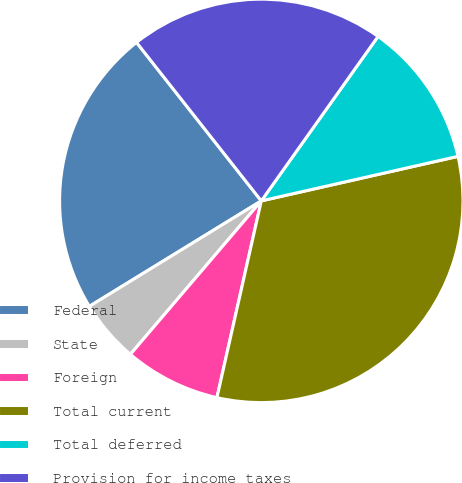<chart> <loc_0><loc_0><loc_500><loc_500><pie_chart><fcel>Federal<fcel>State<fcel>Foreign<fcel>Total current<fcel>Total deferred<fcel>Provision for income taxes<nl><fcel>23.14%<fcel>5.0%<fcel>7.71%<fcel>32.07%<fcel>11.63%<fcel>20.44%<nl></chart> 